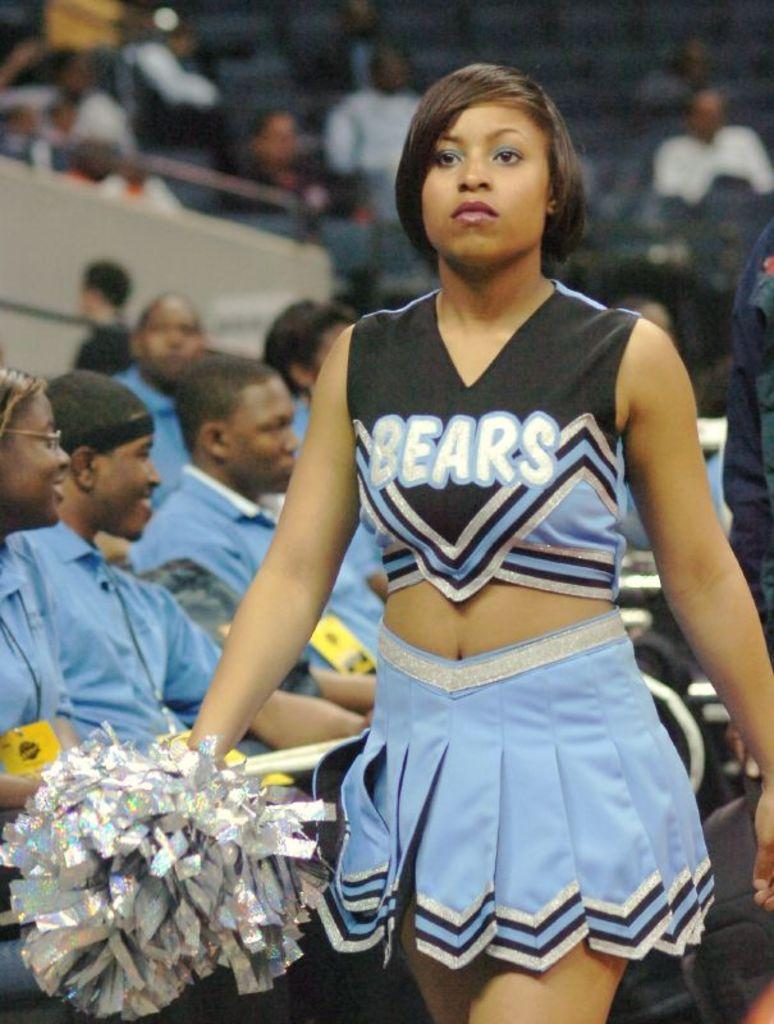<image>
Give a short and clear explanation of the subsequent image. A Bears cheerleader is walking and holding her pom pom. 